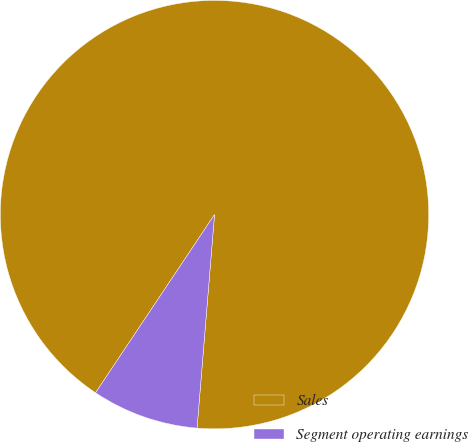Convert chart. <chart><loc_0><loc_0><loc_500><loc_500><pie_chart><fcel>Sales<fcel>Segment operating earnings<nl><fcel>91.93%<fcel>8.07%<nl></chart> 